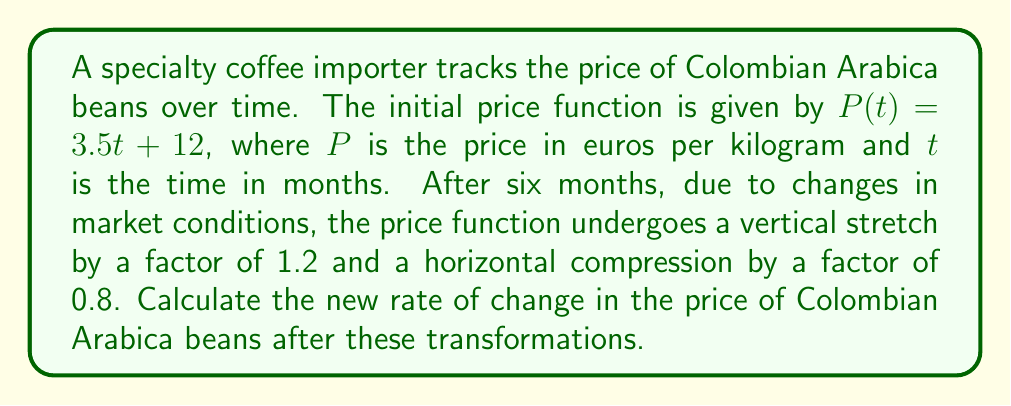Can you solve this math problem? 1) The initial price function is $P(t) = 3.5t + 12$
   The initial rate of change (slope) is 3.5 euros per month.

2) After the transformations:
   - Vertical stretch by a factor of 1.2: $1.2(3.5t + 12)$
   - Horizontal compression by a factor of 0.8: $1.2(3.5(\frac{t}{0.8}) + 12)$

3) Simplify the new function:
   $P_{new}(t) = 1.2(3.5(\frac{t}{0.8}) + 12)$
   $P_{new}(t) = 1.2(\frac{3.5t}{0.8} + 12)$
   $P_{new}(t) = 1.2(\frac{35t}{8} + 12)$
   $P_{new}(t) = \frac{42t}{8} + 14.4$
   $P_{new}(t) = 5.25t + 14.4$

4) The new rate of change is the coefficient of $t$ in the transformed function:
   New rate of change = 5.25 euros per month

5) Verify:
   Initial rate * vertical stretch / horizontal compression
   $3.5 * 1.2 / 0.8 = 5.25$

Thus, the new rate of change is 5.25 euros per month.
Answer: 5.25 euros/month 